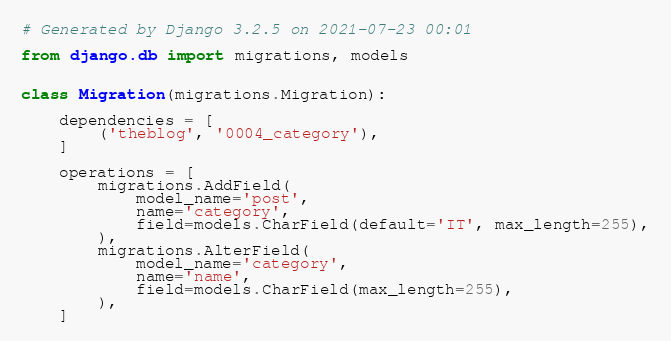Convert code to text. <code><loc_0><loc_0><loc_500><loc_500><_Python_># Generated by Django 3.2.5 on 2021-07-23 00:01

from django.db import migrations, models


class Migration(migrations.Migration):

    dependencies = [
        ('theblog', '0004_category'),
    ]

    operations = [
        migrations.AddField(
            model_name='post',
            name='category',
            field=models.CharField(default='IT', max_length=255),
        ),
        migrations.AlterField(
            model_name='category',
            name='name',
            field=models.CharField(max_length=255),
        ),
    ]
</code> 